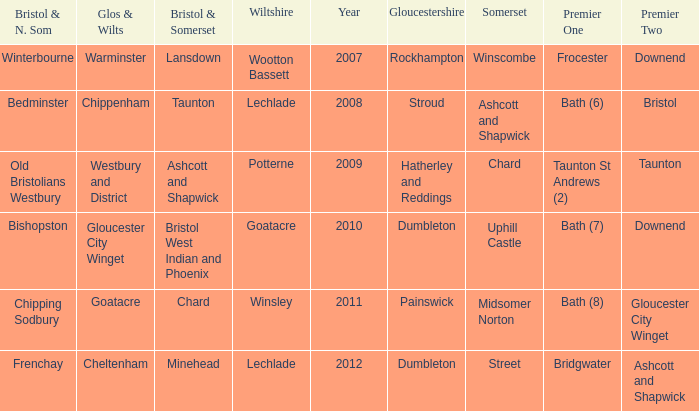What is the bristol & n. som where the somerset is ashcott and shapwick? Bedminster. 